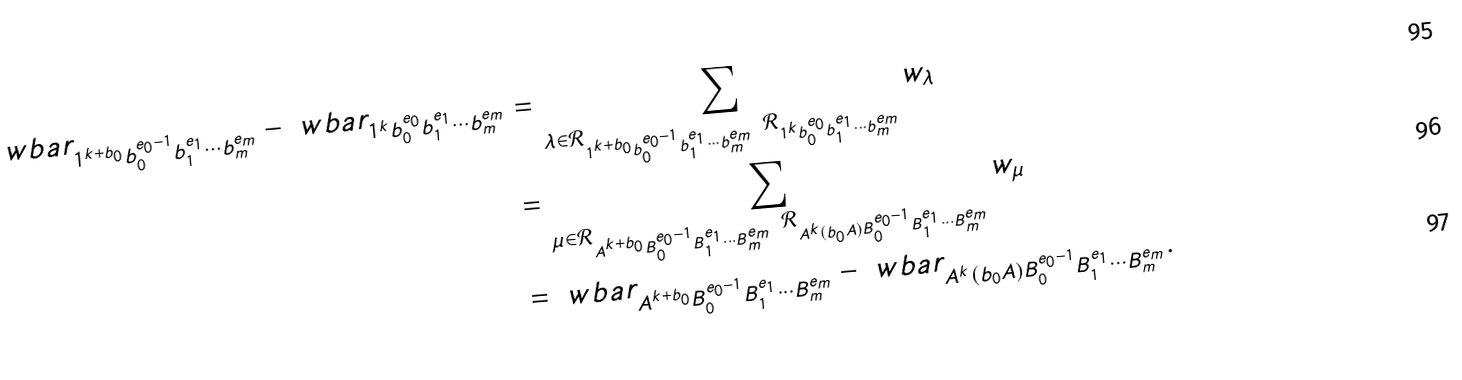<formula> <loc_0><loc_0><loc_500><loc_500>\ w b a r _ { 1 ^ { k + b _ { 0 } } b _ { 0 } ^ { e _ { 0 } - 1 } b _ { 1 } ^ { e _ { 1 } } \cdots b _ { m } ^ { e _ { m } } } - \ w b a r _ { 1 ^ { k } b _ { 0 } ^ { e _ { 0 } } b _ { 1 } ^ { e _ { 1 } } \cdots b _ { m } ^ { e _ { m } } } & = \sum _ { \lambda \in \mathcal { R } _ { 1 ^ { k + b _ { 0 } } b _ { 0 } ^ { e _ { 0 } - 1 } b _ { 1 } ^ { e _ { 1 } } \cdots b _ { m } ^ { e _ { m } } } \ \mathcal { R } _ { 1 ^ { k } b _ { 0 } ^ { e _ { 0 } } b _ { 1 } ^ { e _ { 1 } } \cdots b _ { m } ^ { e _ { m } } } } w _ { \lambda } \\ & = \sum _ { \mu \in \mathcal { R } _ { A ^ { k + b _ { 0 } } B _ { 0 } ^ { e _ { 0 } - 1 } B _ { 1 } ^ { e _ { 1 } } \cdots B _ { m } ^ { e _ { m } } } \ \mathcal { R } _ { A ^ { k } ( b _ { 0 } A ) B _ { 0 } ^ { e _ { 0 } - 1 } B _ { 1 } ^ { e _ { 1 } } \cdots B _ { m } ^ { e _ { m } } } } w _ { \mu } \\ & = \ w b a r _ { A ^ { k + b _ { 0 } } B _ { 0 } ^ { e _ { 0 } - 1 } B _ { 1 } ^ { e _ { 1 } } \cdots B _ { m } ^ { e _ { m } } } - \ w b a r _ { A ^ { k } ( b _ { 0 } A ) B _ { 0 } ^ { e _ { 0 } - 1 } B _ { 1 } ^ { e _ { 1 } } \cdots B _ { m } ^ { e _ { m } } } .</formula> 